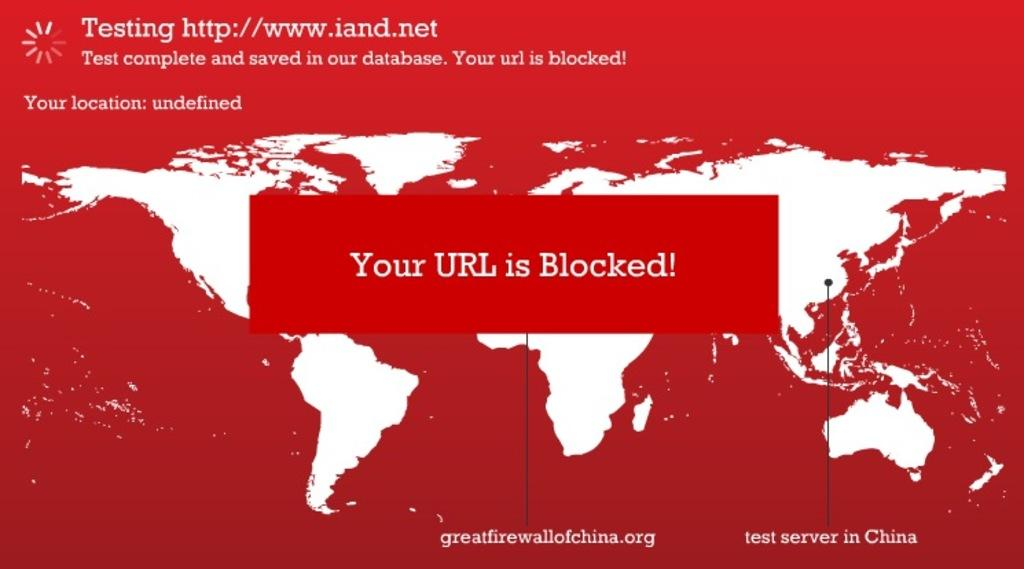<image>
Relay a brief, clear account of the picture shown. a warning the a URL was blocked on a testing site 